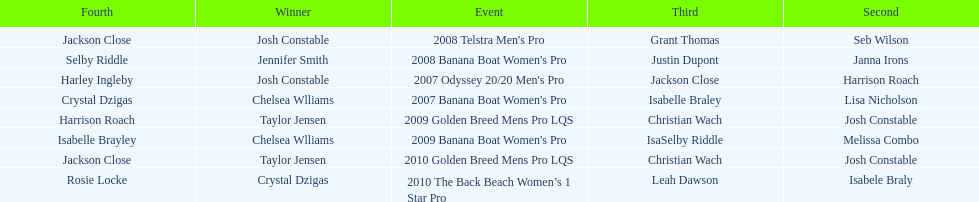At which event did taylor jensen first win? 2009 Golden Breed Mens Pro LQS. 